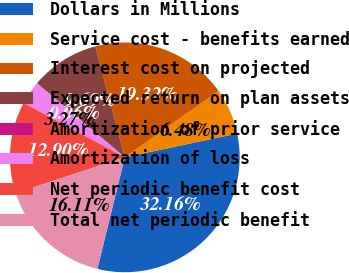Convert chart. <chart><loc_0><loc_0><loc_500><loc_500><pie_chart><fcel>Dollars in Millions<fcel>Service cost - benefits earned<fcel>Interest cost on projected<fcel>Expected return on plan assets<fcel>Amortization of prior service<fcel>Amortization of loss<fcel>Net periodic benefit cost<fcel>Total net periodic benefit<nl><fcel>32.16%<fcel>6.48%<fcel>19.32%<fcel>9.69%<fcel>0.06%<fcel>3.27%<fcel>12.9%<fcel>16.11%<nl></chart> 